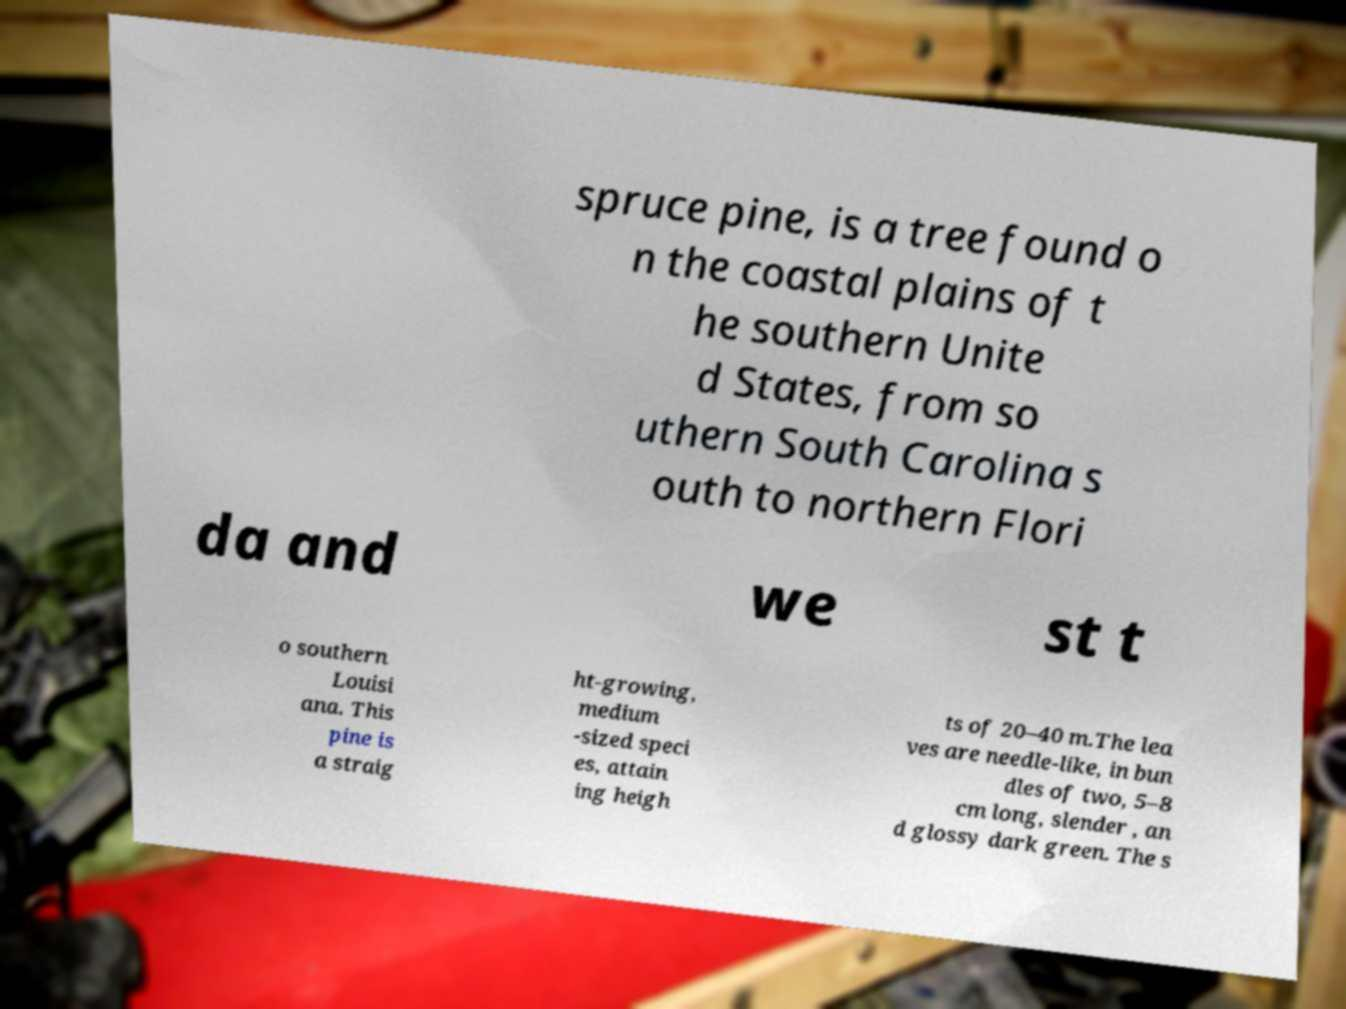Can you read and provide the text displayed in the image?This photo seems to have some interesting text. Can you extract and type it out for me? spruce pine, is a tree found o n the coastal plains of t he southern Unite d States, from so uthern South Carolina s outh to northern Flori da and we st t o southern Louisi ana. This pine is a straig ht-growing, medium -sized speci es, attain ing heigh ts of 20–40 m.The lea ves are needle-like, in bun dles of two, 5–8 cm long, slender , an d glossy dark green. The s 